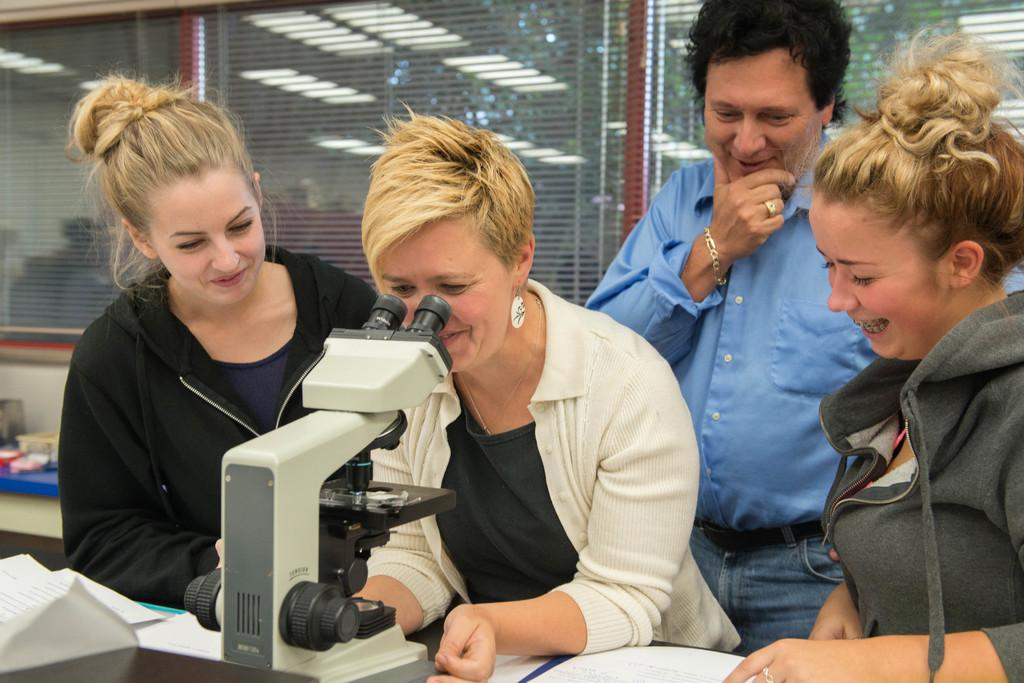What can be seen in the image involving people? There are people standing in the image. What scientific instrument is present in the image? There is a microscope in the image. What architectural feature is visible in the image? There are windows in the image. What type of object is related to documentation or study in the image? There are papers in the image. Can you tell me how many people are shaking hands in the image? There is no indication of people shaking hands in the image; they are simply standing. Is there a faucet visible in the image? There is no faucet present in the image. 